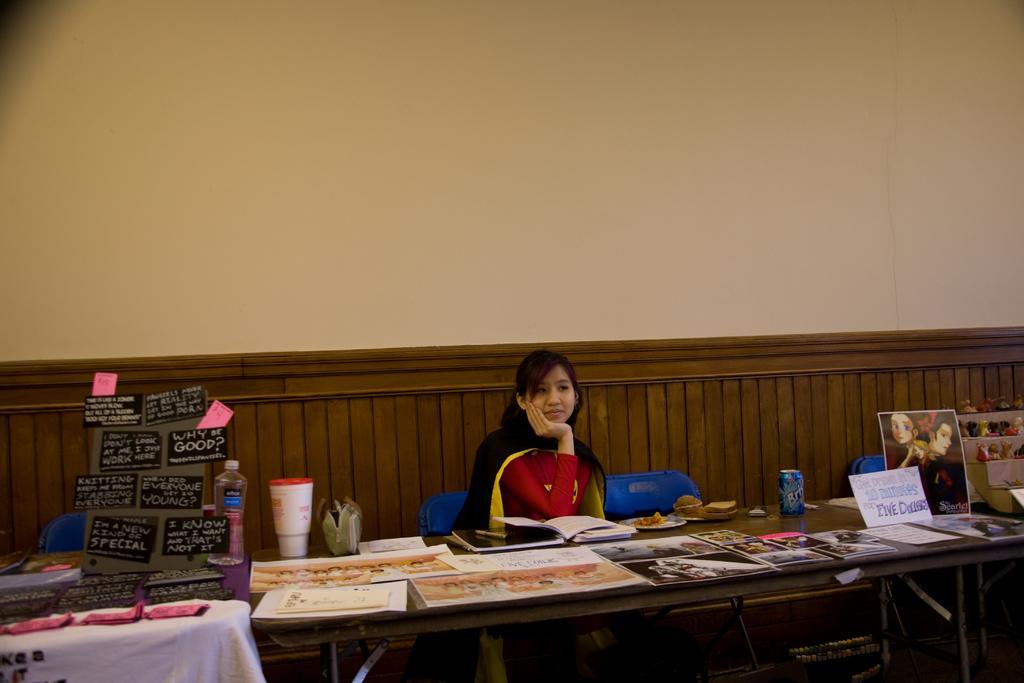Could you give a brief overview of what you see in this image? There is a woman sitting on the chair at the table. On the table there are poster,water bottle,hoardings. In the background there is a wall. 